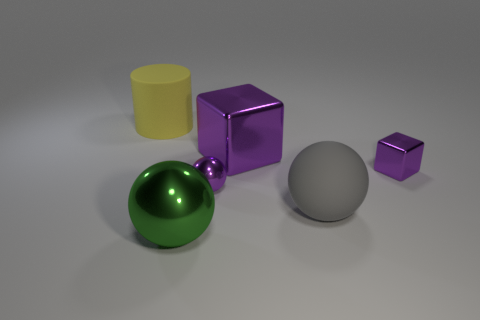What number of other shiny spheres have the same color as the tiny sphere?
Ensure brevity in your answer.  0. The tiny purple sphere that is behind the big matte thing that is in front of the large cylinder is made of what material?
Offer a terse response. Metal. The purple metallic ball is what size?
Offer a very short reply. Small. What number of purple rubber objects are the same size as the yellow cylinder?
Your answer should be very brief. 0. What number of small yellow shiny objects have the same shape as the large green object?
Ensure brevity in your answer.  0. Are there an equal number of big shiny cubes in front of the large gray matte sphere and big cylinders?
Your answer should be compact. No. Is there any other thing that is the same size as the gray matte ball?
Your answer should be very brief. Yes. What shape is the gray thing that is the same size as the yellow cylinder?
Provide a short and direct response. Sphere. Is there a large gray rubber thing that has the same shape as the large yellow thing?
Keep it short and to the point. No. There is a large green thing in front of the rubber object that is in front of the big yellow matte cylinder; is there a tiny purple shiny block that is in front of it?
Provide a short and direct response. No. 